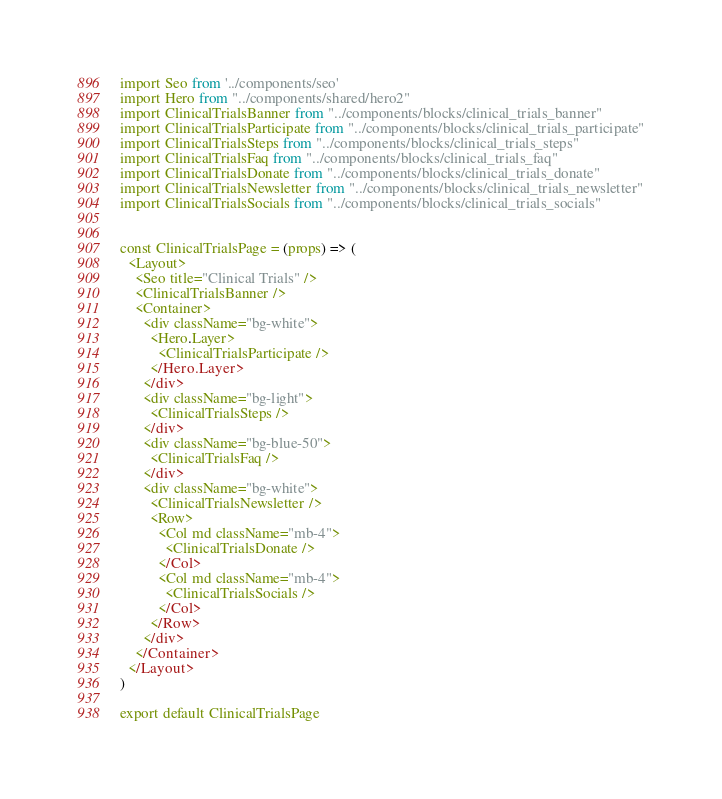<code> <loc_0><loc_0><loc_500><loc_500><_JavaScript_>import Seo from '../components/seo'
import Hero from "../components/shared/hero2"
import ClinicalTrialsBanner from "../components/blocks/clinical_trials_banner"
import ClinicalTrialsParticipate from "../components/blocks/clinical_trials_participate"
import ClinicalTrialsSteps from "../components/blocks/clinical_trials_steps"
import ClinicalTrialsFaq from "../components/blocks/clinical_trials_faq"
import ClinicalTrialsDonate from "../components/blocks/clinical_trials_donate"
import ClinicalTrialsNewsletter from "../components/blocks/clinical_trials_newsletter"
import ClinicalTrialsSocials from "../components/blocks/clinical_trials_socials"


const ClinicalTrialsPage = (props) => (
  <Layout>
    <Seo title="Clinical Trials" />
    <ClinicalTrialsBanner />
    <Container>
      <div className="bg-white">
        <Hero.Layer>
          <ClinicalTrialsParticipate />
        </Hero.Layer>
      </div>
      <div className="bg-light">
        <ClinicalTrialsSteps />
      </div>
      <div className="bg-blue-50">
        <ClinicalTrialsFaq />
      </div>
      <div className="bg-white">
        <ClinicalTrialsNewsletter />
        <Row>
          <Col md className="mb-4">
            <ClinicalTrialsDonate />
          </Col>
          <Col md className="mb-4">
            <ClinicalTrialsSocials />
          </Col>
        </Row>
      </div>
    </Container>
  </Layout>
)

export default ClinicalTrialsPage

</code> 